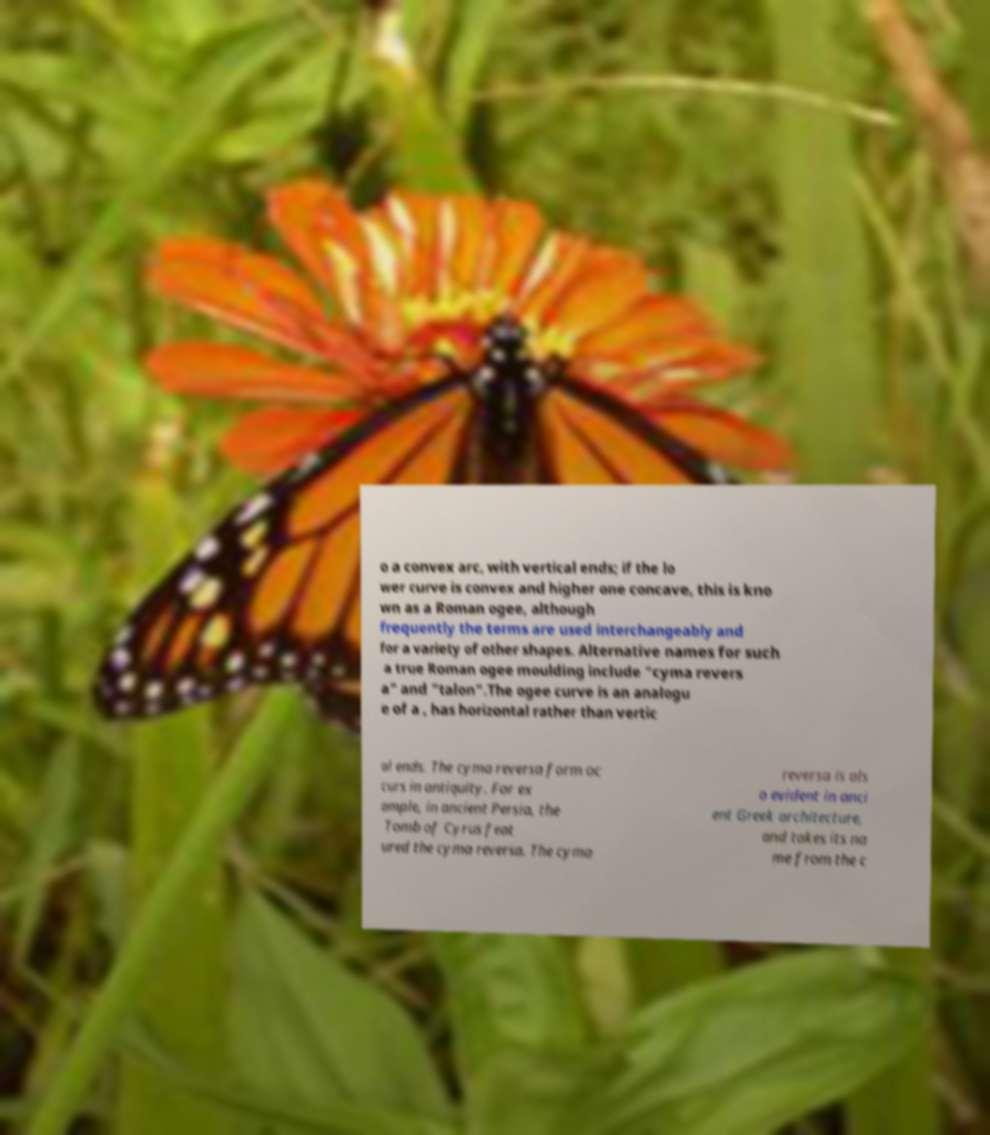Could you assist in decoding the text presented in this image and type it out clearly? o a convex arc, with vertical ends; if the lo wer curve is convex and higher one concave, this is kno wn as a Roman ogee, although frequently the terms are used interchangeably and for a variety of other shapes. Alternative names for such a true Roman ogee moulding include "cyma revers a" and "talon".The ogee curve is an analogu e of a , has horizontal rather than vertic al ends. The cyma reversa form oc curs in antiquity. For ex ample, in ancient Persia, the Tomb of Cyrus feat ured the cyma reversa. The cyma reversa is als o evident in anci ent Greek architecture, and takes its na me from the c 